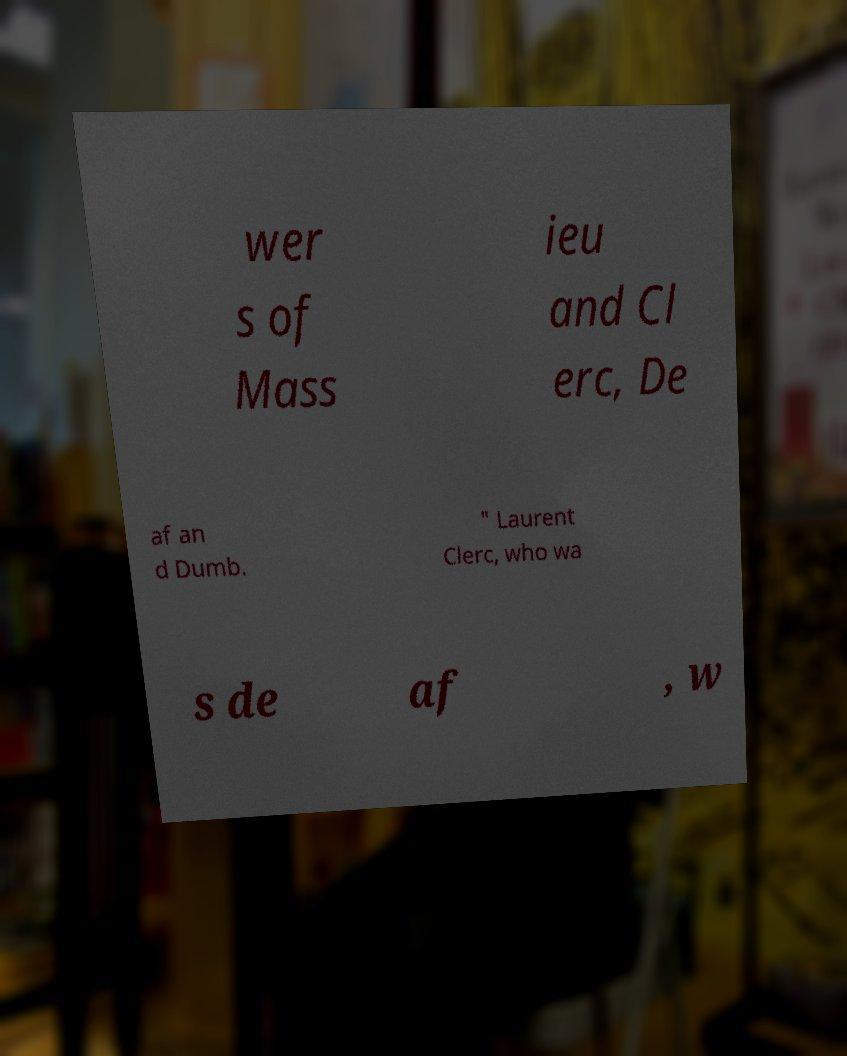For documentation purposes, I need the text within this image transcribed. Could you provide that? wer s of Mass ieu and Cl erc, De af an d Dumb. " Laurent Clerc, who wa s de af , w 